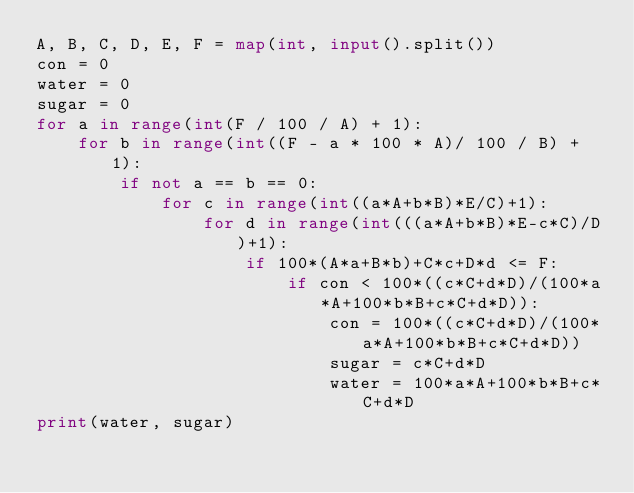Convert code to text. <code><loc_0><loc_0><loc_500><loc_500><_Python_>A, B, C, D, E, F = map(int, input().split())
con = 0
water = 0
sugar = 0
for a in range(int(F / 100 / A) + 1):
    for b in range(int((F - a * 100 * A)/ 100 / B) + 1):
        if not a == b == 0:
            for c in range(int((a*A+b*B)*E/C)+1):
                for d in range(int(((a*A+b*B)*E-c*C)/D)+1):
                    if 100*(A*a+B*b)+C*c+D*d <= F:
                        if con < 100*((c*C+d*D)/(100*a*A+100*b*B+c*C+d*D)):
                            con = 100*((c*C+d*D)/(100*a*A+100*b*B+c*C+d*D))
                            sugar = c*C+d*D
                            water = 100*a*A+100*b*B+c*C+d*D
print(water, sugar)</code> 